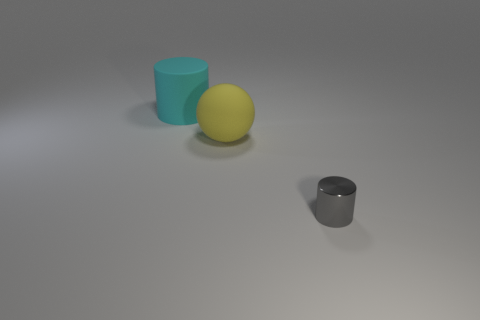There is a large object that is in front of the cylinder that is behind the tiny shiny thing; is there a large cyan rubber object that is to the right of it?
Keep it short and to the point. No. How big is the rubber object right of the matte cylinder?
Keep it short and to the point. Large. Does the yellow thing have the same shape as the gray metal thing?
Your answer should be compact. No. What number of things are big yellow spheres or big rubber things on the right side of the cyan object?
Offer a terse response. 1. Is the size of the matte thing behind the yellow ball the same as the yellow matte thing?
Make the answer very short. Yes. There is a large rubber object that is behind the big thing that is in front of the big cyan rubber cylinder; what number of matte things are to the right of it?
Provide a succinct answer. 1. What number of cyan objects are either big rubber objects or big matte cylinders?
Your answer should be compact. 1. There is a sphere that is made of the same material as the big cylinder; what is its color?
Provide a succinct answer. Yellow. Is there any other thing that has the same size as the metal thing?
Your answer should be very brief. No. What number of small things are either purple objects or cyan matte objects?
Offer a very short reply. 0. 